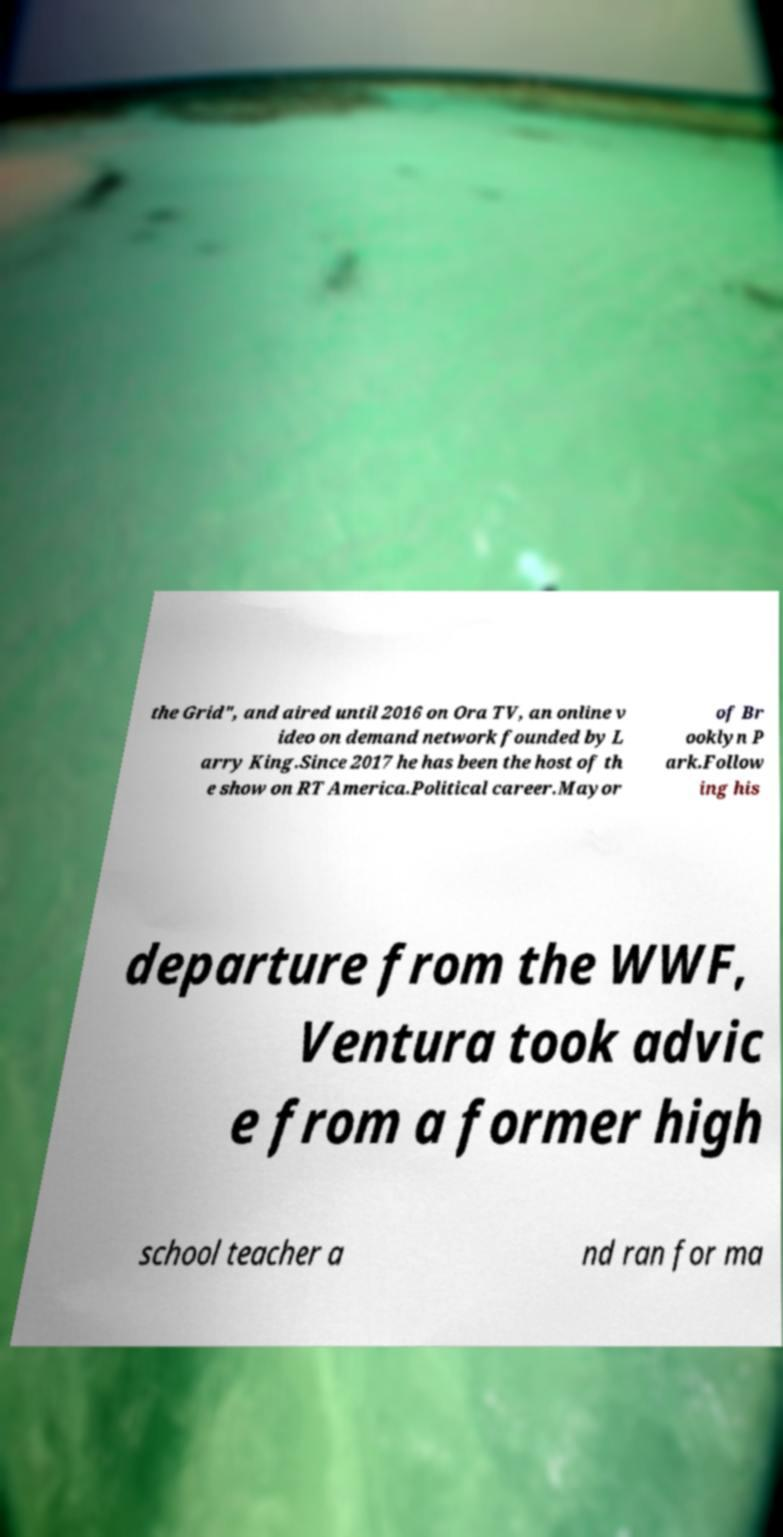Please read and relay the text visible in this image. What does it say? the Grid", and aired until 2016 on Ora TV, an online v ideo on demand network founded by L arry King.Since 2017 he has been the host of th e show on RT America.Political career.Mayor of Br ooklyn P ark.Follow ing his departure from the WWF, Ventura took advic e from a former high school teacher a nd ran for ma 